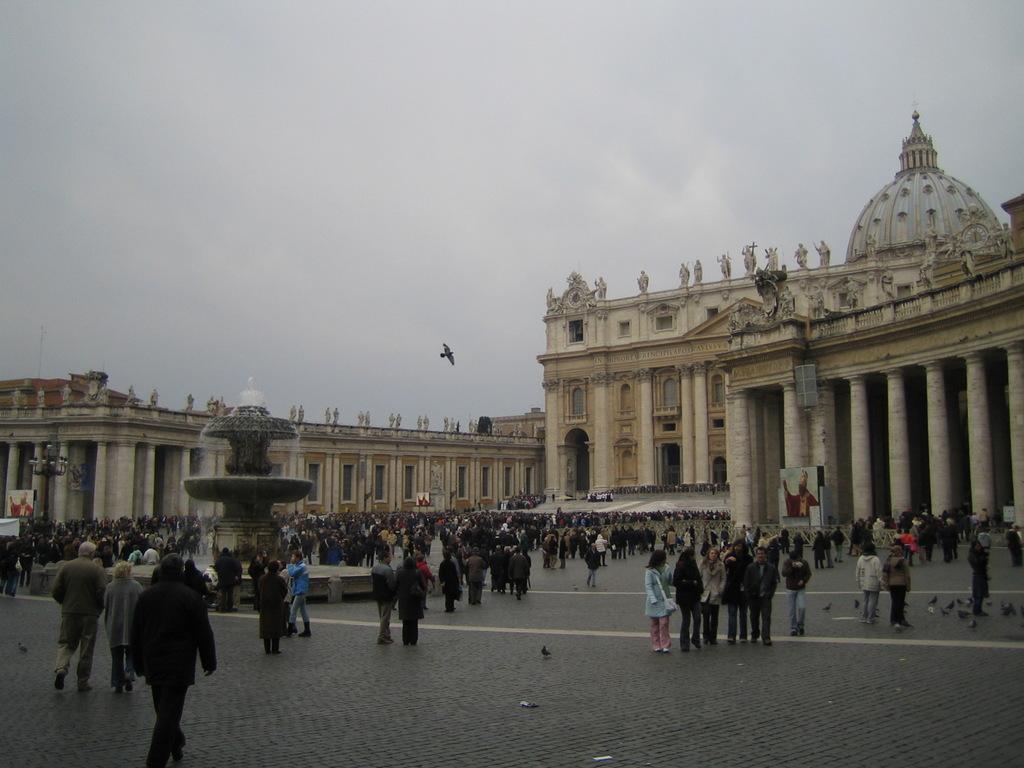How would you summarize this image in a sentence or two? In this image we can see crowd. In the back there is a fountain. In the background there are buildings with pillars. On the building there are statues. Also there is sky. And there is a bird flying. On the ground there are birds. 